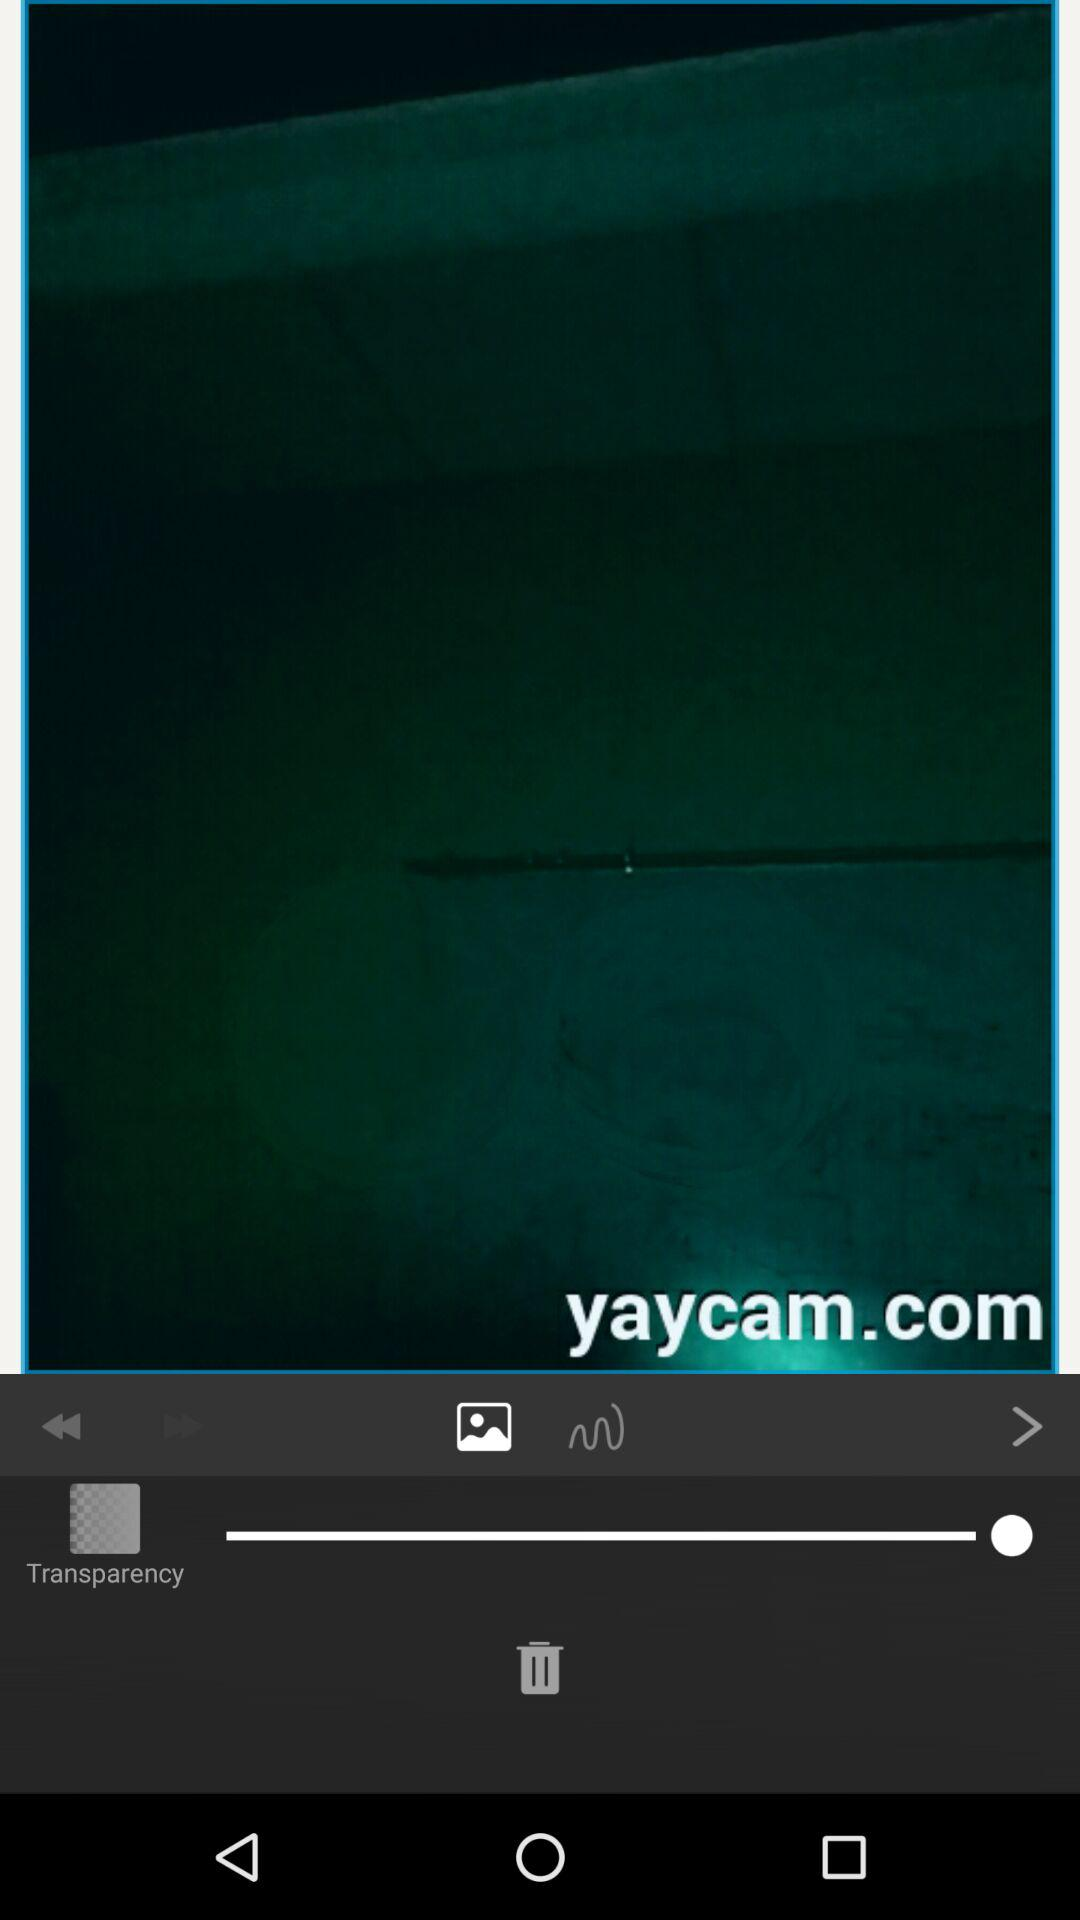Who posted the image?
When the provided information is insufficient, respond with <no answer>. <no answer> 